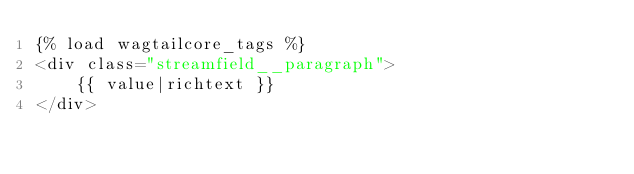<code> <loc_0><loc_0><loc_500><loc_500><_HTML_>{% load wagtailcore_tags %}
<div class="streamfield__paragraph">
    {{ value|richtext }}
</div>
</code> 